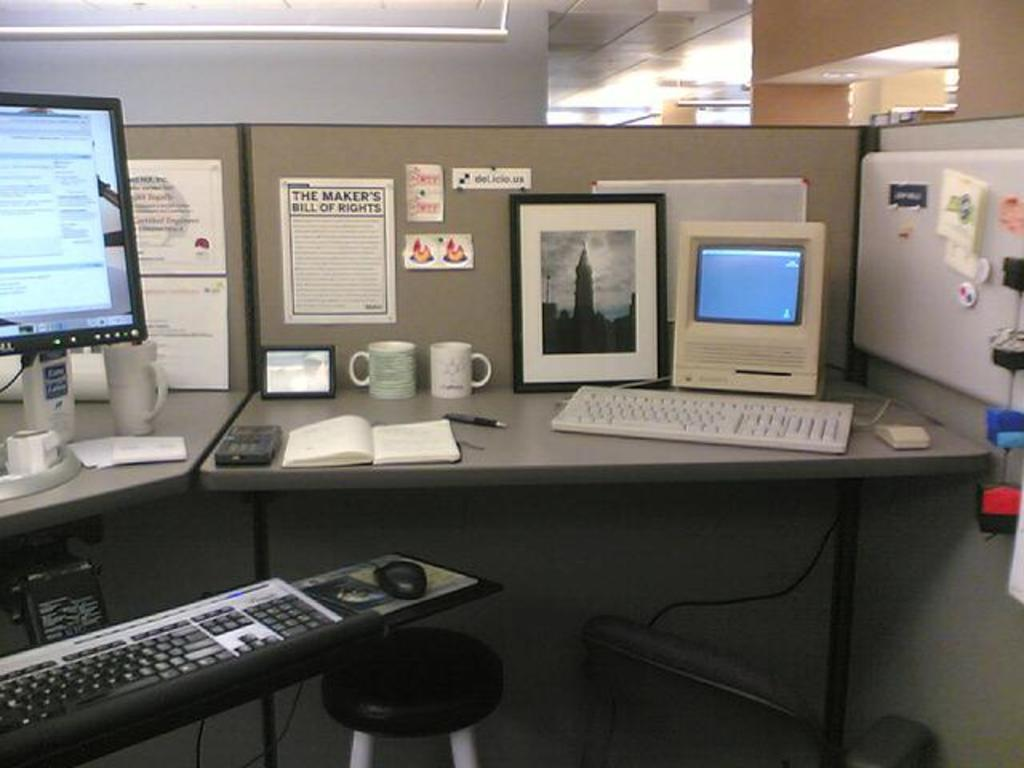<image>
Relay a brief, clear account of the picture shown. An office cubicle with The Maker's Bill of Rights on the wall. 